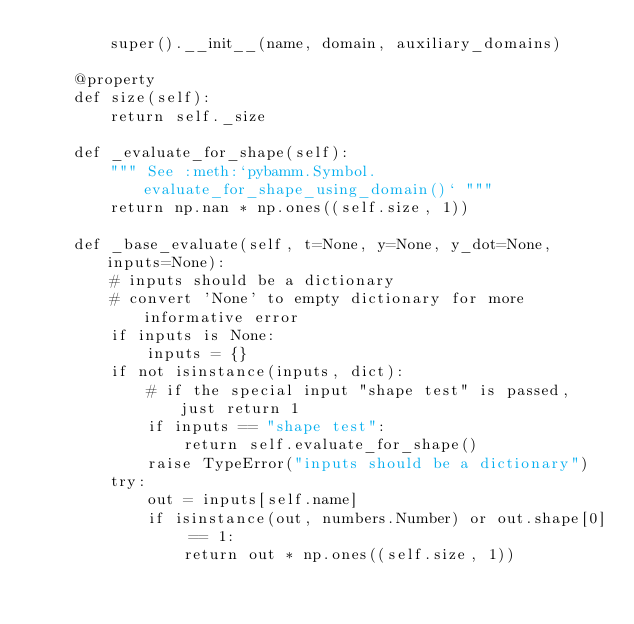Convert code to text. <code><loc_0><loc_0><loc_500><loc_500><_Python_>        super().__init__(name, domain, auxiliary_domains)

    @property
    def size(self):
        return self._size

    def _evaluate_for_shape(self):
        """ See :meth:`pybamm.Symbol.evaluate_for_shape_using_domain()` """
        return np.nan * np.ones((self.size, 1))

    def _base_evaluate(self, t=None, y=None, y_dot=None, inputs=None):
        # inputs should be a dictionary
        # convert 'None' to empty dictionary for more informative error
        if inputs is None:
            inputs = {}
        if not isinstance(inputs, dict):
            # if the special input "shape test" is passed, just return 1
            if inputs == "shape test":
                return self.evaluate_for_shape()
            raise TypeError("inputs should be a dictionary")
        try:
            out = inputs[self.name]
            if isinstance(out, numbers.Number) or out.shape[0] == 1:
                return out * np.ones((self.size, 1))</code> 